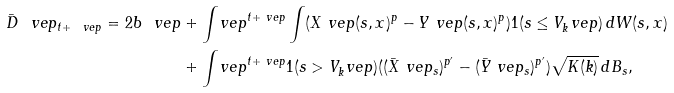Convert formula to latex. <formula><loc_0><loc_0><loc_500><loc_500>\bar { D } ^ { \ } v e p _ { t + \ v e p } = 2 b \ v e p & + \int _ { \ } v e p ^ { t + \ v e p } \int ( X ^ { \ } v e p ( s , x ) ^ { p } - Y ^ { \ } v e p ( s , x ) ^ { p } ) 1 ( s \leq V _ { k } ^ { \ } v e p ) \, d W ( s , x ) \\ & + \int _ { \ } v e p ^ { t + \ v e p } 1 ( s > V _ { k } ^ { \ } v e p ) ( ( \bar { X } ^ { \ } v e p _ { s } ) ^ { p ^ { \prime } } - ( \bar { Y } ^ { \ } v e p _ { s } ) ^ { p ^ { \prime } } ) \sqrt { K ( k ) } \, d B _ { s } ,</formula> 